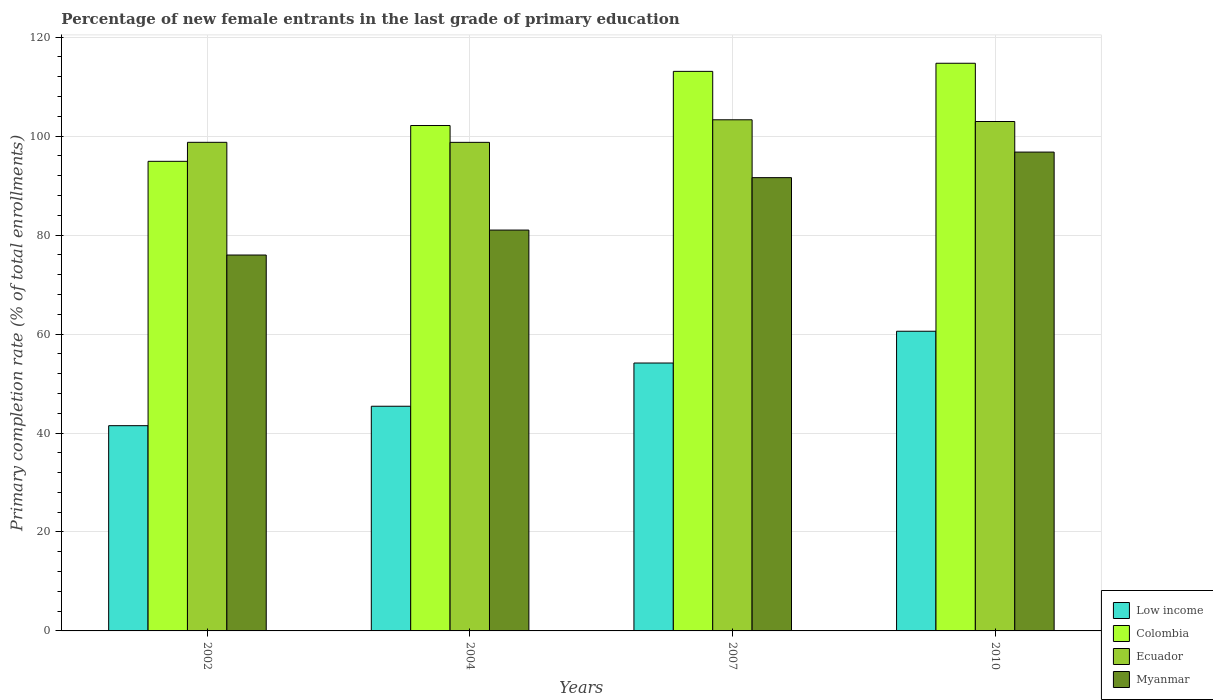How many different coloured bars are there?
Your response must be concise. 4. How many groups of bars are there?
Keep it short and to the point. 4. Are the number of bars on each tick of the X-axis equal?
Your answer should be compact. Yes. How many bars are there on the 4th tick from the left?
Provide a succinct answer. 4. In how many cases, is the number of bars for a given year not equal to the number of legend labels?
Ensure brevity in your answer.  0. What is the percentage of new female entrants in Ecuador in 2010?
Your answer should be very brief. 102.95. Across all years, what is the maximum percentage of new female entrants in Colombia?
Your response must be concise. 114.73. Across all years, what is the minimum percentage of new female entrants in Myanmar?
Give a very brief answer. 75.97. What is the total percentage of new female entrants in Colombia in the graph?
Your response must be concise. 424.87. What is the difference between the percentage of new female entrants in Myanmar in 2004 and that in 2007?
Make the answer very short. -10.6. What is the difference between the percentage of new female entrants in Colombia in 2007 and the percentage of new female entrants in Ecuador in 2004?
Offer a very short reply. 14.35. What is the average percentage of new female entrants in Colombia per year?
Provide a succinct answer. 106.22. In the year 2004, what is the difference between the percentage of new female entrants in Ecuador and percentage of new female entrants in Low income?
Your response must be concise. 53.34. In how many years, is the percentage of new female entrants in Colombia greater than 72 %?
Keep it short and to the point. 4. What is the ratio of the percentage of new female entrants in Myanmar in 2002 to that in 2010?
Give a very brief answer. 0.79. What is the difference between the highest and the second highest percentage of new female entrants in Low income?
Your response must be concise. 6.42. What is the difference between the highest and the lowest percentage of new female entrants in Low income?
Keep it short and to the point. 19.09. Is the sum of the percentage of new female entrants in Ecuador in 2007 and 2010 greater than the maximum percentage of new female entrants in Myanmar across all years?
Your answer should be very brief. Yes. What does the 4th bar from the left in 2002 represents?
Give a very brief answer. Myanmar. What does the 2nd bar from the right in 2007 represents?
Your answer should be compact. Ecuador. How many bars are there?
Make the answer very short. 16. Are all the bars in the graph horizontal?
Provide a short and direct response. No. What is the difference between two consecutive major ticks on the Y-axis?
Offer a terse response. 20. Are the values on the major ticks of Y-axis written in scientific E-notation?
Offer a very short reply. No. Does the graph contain grids?
Give a very brief answer. Yes. How are the legend labels stacked?
Your answer should be compact. Vertical. What is the title of the graph?
Give a very brief answer. Percentage of new female entrants in the last grade of primary education. What is the label or title of the X-axis?
Offer a terse response. Years. What is the label or title of the Y-axis?
Your answer should be very brief. Primary completion rate (% of total enrollments). What is the Primary completion rate (% of total enrollments) of Low income in 2002?
Provide a short and direct response. 41.48. What is the Primary completion rate (% of total enrollments) of Colombia in 2002?
Offer a terse response. 94.91. What is the Primary completion rate (% of total enrollments) of Ecuador in 2002?
Your response must be concise. 98.75. What is the Primary completion rate (% of total enrollments) of Myanmar in 2002?
Provide a short and direct response. 75.97. What is the Primary completion rate (% of total enrollments) of Low income in 2004?
Offer a terse response. 45.41. What is the Primary completion rate (% of total enrollments) in Colombia in 2004?
Give a very brief answer. 102.14. What is the Primary completion rate (% of total enrollments) in Ecuador in 2004?
Provide a short and direct response. 98.74. What is the Primary completion rate (% of total enrollments) in Myanmar in 2004?
Your answer should be very brief. 81.01. What is the Primary completion rate (% of total enrollments) in Low income in 2007?
Your answer should be compact. 54.14. What is the Primary completion rate (% of total enrollments) of Colombia in 2007?
Your response must be concise. 113.09. What is the Primary completion rate (% of total enrollments) of Ecuador in 2007?
Keep it short and to the point. 103.3. What is the Primary completion rate (% of total enrollments) in Myanmar in 2007?
Your answer should be compact. 91.61. What is the Primary completion rate (% of total enrollments) in Low income in 2010?
Offer a terse response. 60.57. What is the Primary completion rate (% of total enrollments) of Colombia in 2010?
Give a very brief answer. 114.73. What is the Primary completion rate (% of total enrollments) in Ecuador in 2010?
Keep it short and to the point. 102.95. What is the Primary completion rate (% of total enrollments) in Myanmar in 2010?
Your answer should be very brief. 96.77. Across all years, what is the maximum Primary completion rate (% of total enrollments) in Low income?
Keep it short and to the point. 60.57. Across all years, what is the maximum Primary completion rate (% of total enrollments) in Colombia?
Keep it short and to the point. 114.73. Across all years, what is the maximum Primary completion rate (% of total enrollments) of Ecuador?
Offer a terse response. 103.3. Across all years, what is the maximum Primary completion rate (% of total enrollments) in Myanmar?
Ensure brevity in your answer.  96.77. Across all years, what is the minimum Primary completion rate (% of total enrollments) of Low income?
Your response must be concise. 41.48. Across all years, what is the minimum Primary completion rate (% of total enrollments) in Colombia?
Offer a very short reply. 94.91. Across all years, what is the minimum Primary completion rate (% of total enrollments) in Ecuador?
Your answer should be very brief. 98.74. Across all years, what is the minimum Primary completion rate (% of total enrollments) of Myanmar?
Offer a very short reply. 75.97. What is the total Primary completion rate (% of total enrollments) in Low income in the graph?
Your response must be concise. 201.6. What is the total Primary completion rate (% of total enrollments) in Colombia in the graph?
Keep it short and to the point. 424.87. What is the total Primary completion rate (% of total enrollments) of Ecuador in the graph?
Provide a succinct answer. 403.75. What is the total Primary completion rate (% of total enrollments) of Myanmar in the graph?
Your answer should be very brief. 345.37. What is the difference between the Primary completion rate (% of total enrollments) of Low income in 2002 and that in 2004?
Your answer should be very brief. -3.93. What is the difference between the Primary completion rate (% of total enrollments) of Colombia in 2002 and that in 2004?
Your response must be concise. -7.24. What is the difference between the Primary completion rate (% of total enrollments) in Ecuador in 2002 and that in 2004?
Your answer should be compact. 0. What is the difference between the Primary completion rate (% of total enrollments) in Myanmar in 2002 and that in 2004?
Give a very brief answer. -5.04. What is the difference between the Primary completion rate (% of total enrollments) of Low income in 2002 and that in 2007?
Offer a very short reply. -12.66. What is the difference between the Primary completion rate (% of total enrollments) of Colombia in 2002 and that in 2007?
Provide a short and direct response. -18.18. What is the difference between the Primary completion rate (% of total enrollments) of Ecuador in 2002 and that in 2007?
Make the answer very short. -4.55. What is the difference between the Primary completion rate (% of total enrollments) in Myanmar in 2002 and that in 2007?
Ensure brevity in your answer.  -15.64. What is the difference between the Primary completion rate (% of total enrollments) in Low income in 2002 and that in 2010?
Provide a succinct answer. -19.09. What is the difference between the Primary completion rate (% of total enrollments) in Colombia in 2002 and that in 2010?
Offer a terse response. -19.82. What is the difference between the Primary completion rate (% of total enrollments) of Ecuador in 2002 and that in 2010?
Your answer should be compact. -4.21. What is the difference between the Primary completion rate (% of total enrollments) in Myanmar in 2002 and that in 2010?
Your response must be concise. -20.8. What is the difference between the Primary completion rate (% of total enrollments) in Low income in 2004 and that in 2007?
Offer a very short reply. -8.73. What is the difference between the Primary completion rate (% of total enrollments) in Colombia in 2004 and that in 2007?
Your answer should be very brief. -10.94. What is the difference between the Primary completion rate (% of total enrollments) in Ecuador in 2004 and that in 2007?
Give a very brief answer. -4.56. What is the difference between the Primary completion rate (% of total enrollments) in Myanmar in 2004 and that in 2007?
Keep it short and to the point. -10.6. What is the difference between the Primary completion rate (% of total enrollments) of Low income in 2004 and that in 2010?
Your answer should be compact. -15.16. What is the difference between the Primary completion rate (% of total enrollments) of Colombia in 2004 and that in 2010?
Give a very brief answer. -12.58. What is the difference between the Primary completion rate (% of total enrollments) in Ecuador in 2004 and that in 2010?
Offer a very short reply. -4.21. What is the difference between the Primary completion rate (% of total enrollments) in Myanmar in 2004 and that in 2010?
Keep it short and to the point. -15.76. What is the difference between the Primary completion rate (% of total enrollments) in Low income in 2007 and that in 2010?
Your response must be concise. -6.42. What is the difference between the Primary completion rate (% of total enrollments) of Colombia in 2007 and that in 2010?
Give a very brief answer. -1.64. What is the difference between the Primary completion rate (% of total enrollments) of Ecuador in 2007 and that in 2010?
Keep it short and to the point. 0.35. What is the difference between the Primary completion rate (% of total enrollments) in Myanmar in 2007 and that in 2010?
Make the answer very short. -5.17. What is the difference between the Primary completion rate (% of total enrollments) in Low income in 2002 and the Primary completion rate (% of total enrollments) in Colombia in 2004?
Make the answer very short. -60.66. What is the difference between the Primary completion rate (% of total enrollments) of Low income in 2002 and the Primary completion rate (% of total enrollments) of Ecuador in 2004?
Make the answer very short. -57.26. What is the difference between the Primary completion rate (% of total enrollments) of Low income in 2002 and the Primary completion rate (% of total enrollments) of Myanmar in 2004?
Your answer should be compact. -39.53. What is the difference between the Primary completion rate (% of total enrollments) in Colombia in 2002 and the Primary completion rate (% of total enrollments) in Ecuador in 2004?
Keep it short and to the point. -3.83. What is the difference between the Primary completion rate (% of total enrollments) in Colombia in 2002 and the Primary completion rate (% of total enrollments) in Myanmar in 2004?
Offer a terse response. 13.9. What is the difference between the Primary completion rate (% of total enrollments) of Ecuador in 2002 and the Primary completion rate (% of total enrollments) of Myanmar in 2004?
Provide a short and direct response. 17.74. What is the difference between the Primary completion rate (% of total enrollments) in Low income in 2002 and the Primary completion rate (% of total enrollments) in Colombia in 2007?
Offer a terse response. -71.61. What is the difference between the Primary completion rate (% of total enrollments) in Low income in 2002 and the Primary completion rate (% of total enrollments) in Ecuador in 2007?
Your answer should be compact. -61.82. What is the difference between the Primary completion rate (% of total enrollments) of Low income in 2002 and the Primary completion rate (% of total enrollments) of Myanmar in 2007?
Ensure brevity in your answer.  -50.13. What is the difference between the Primary completion rate (% of total enrollments) of Colombia in 2002 and the Primary completion rate (% of total enrollments) of Ecuador in 2007?
Provide a succinct answer. -8.39. What is the difference between the Primary completion rate (% of total enrollments) of Colombia in 2002 and the Primary completion rate (% of total enrollments) of Myanmar in 2007?
Offer a very short reply. 3.3. What is the difference between the Primary completion rate (% of total enrollments) in Ecuador in 2002 and the Primary completion rate (% of total enrollments) in Myanmar in 2007?
Your answer should be very brief. 7.14. What is the difference between the Primary completion rate (% of total enrollments) of Low income in 2002 and the Primary completion rate (% of total enrollments) of Colombia in 2010?
Give a very brief answer. -73.25. What is the difference between the Primary completion rate (% of total enrollments) in Low income in 2002 and the Primary completion rate (% of total enrollments) in Ecuador in 2010?
Keep it short and to the point. -61.47. What is the difference between the Primary completion rate (% of total enrollments) of Low income in 2002 and the Primary completion rate (% of total enrollments) of Myanmar in 2010?
Offer a very short reply. -55.29. What is the difference between the Primary completion rate (% of total enrollments) of Colombia in 2002 and the Primary completion rate (% of total enrollments) of Ecuador in 2010?
Offer a terse response. -8.05. What is the difference between the Primary completion rate (% of total enrollments) of Colombia in 2002 and the Primary completion rate (% of total enrollments) of Myanmar in 2010?
Ensure brevity in your answer.  -1.87. What is the difference between the Primary completion rate (% of total enrollments) of Ecuador in 2002 and the Primary completion rate (% of total enrollments) of Myanmar in 2010?
Offer a very short reply. 1.97. What is the difference between the Primary completion rate (% of total enrollments) in Low income in 2004 and the Primary completion rate (% of total enrollments) in Colombia in 2007?
Your answer should be compact. -67.68. What is the difference between the Primary completion rate (% of total enrollments) in Low income in 2004 and the Primary completion rate (% of total enrollments) in Ecuador in 2007?
Your answer should be very brief. -57.9. What is the difference between the Primary completion rate (% of total enrollments) in Low income in 2004 and the Primary completion rate (% of total enrollments) in Myanmar in 2007?
Offer a terse response. -46.2. What is the difference between the Primary completion rate (% of total enrollments) in Colombia in 2004 and the Primary completion rate (% of total enrollments) in Ecuador in 2007?
Ensure brevity in your answer.  -1.16. What is the difference between the Primary completion rate (% of total enrollments) in Colombia in 2004 and the Primary completion rate (% of total enrollments) in Myanmar in 2007?
Your answer should be compact. 10.54. What is the difference between the Primary completion rate (% of total enrollments) in Ecuador in 2004 and the Primary completion rate (% of total enrollments) in Myanmar in 2007?
Give a very brief answer. 7.13. What is the difference between the Primary completion rate (% of total enrollments) in Low income in 2004 and the Primary completion rate (% of total enrollments) in Colombia in 2010?
Your response must be concise. -69.32. What is the difference between the Primary completion rate (% of total enrollments) of Low income in 2004 and the Primary completion rate (% of total enrollments) of Ecuador in 2010?
Provide a succinct answer. -57.55. What is the difference between the Primary completion rate (% of total enrollments) of Low income in 2004 and the Primary completion rate (% of total enrollments) of Myanmar in 2010?
Offer a very short reply. -51.37. What is the difference between the Primary completion rate (% of total enrollments) of Colombia in 2004 and the Primary completion rate (% of total enrollments) of Ecuador in 2010?
Keep it short and to the point. -0.81. What is the difference between the Primary completion rate (% of total enrollments) in Colombia in 2004 and the Primary completion rate (% of total enrollments) in Myanmar in 2010?
Keep it short and to the point. 5.37. What is the difference between the Primary completion rate (% of total enrollments) of Ecuador in 2004 and the Primary completion rate (% of total enrollments) of Myanmar in 2010?
Your answer should be compact. 1.97. What is the difference between the Primary completion rate (% of total enrollments) of Low income in 2007 and the Primary completion rate (% of total enrollments) of Colombia in 2010?
Give a very brief answer. -60.58. What is the difference between the Primary completion rate (% of total enrollments) of Low income in 2007 and the Primary completion rate (% of total enrollments) of Ecuador in 2010?
Offer a terse response. -48.81. What is the difference between the Primary completion rate (% of total enrollments) in Low income in 2007 and the Primary completion rate (% of total enrollments) in Myanmar in 2010?
Make the answer very short. -42.63. What is the difference between the Primary completion rate (% of total enrollments) in Colombia in 2007 and the Primary completion rate (% of total enrollments) in Ecuador in 2010?
Provide a succinct answer. 10.13. What is the difference between the Primary completion rate (% of total enrollments) of Colombia in 2007 and the Primary completion rate (% of total enrollments) of Myanmar in 2010?
Offer a terse response. 16.32. What is the difference between the Primary completion rate (% of total enrollments) of Ecuador in 2007 and the Primary completion rate (% of total enrollments) of Myanmar in 2010?
Your response must be concise. 6.53. What is the average Primary completion rate (% of total enrollments) in Low income per year?
Offer a very short reply. 50.4. What is the average Primary completion rate (% of total enrollments) in Colombia per year?
Give a very brief answer. 106.22. What is the average Primary completion rate (% of total enrollments) of Ecuador per year?
Offer a terse response. 100.94. What is the average Primary completion rate (% of total enrollments) in Myanmar per year?
Your response must be concise. 86.34. In the year 2002, what is the difference between the Primary completion rate (% of total enrollments) in Low income and Primary completion rate (% of total enrollments) in Colombia?
Offer a very short reply. -53.43. In the year 2002, what is the difference between the Primary completion rate (% of total enrollments) in Low income and Primary completion rate (% of total enrollments) in Ecuador?
Offer a very short reply. -57.27. In the year 2002, what is the difference between the Primary completion rate (% of total enrollments) in Low income and Primary completion rate (% of total enrollments) in Myanmar?
Ensure brevity in your answer.  -34.49. In the year 2002, what is the difference between the Primary completion rate (% of total enrollments) of Colombia and Primary completion rate (% of total enrollments) of Ecuador?
Give a very brief answer. -3.84. In the year 2002, what is the difference between the Primary completion rate (% of total enrollments) of Colombia and Primary completion rate (% of total enrollments) of Myanmar?
Make the answer very short. 18.94. In the year 2002, what is the difference between the Primary completion rate (% of total enrollments) in Ecuador and Primary completion rate (% of total enrollments) in Myanmar?
Provide a succinct answer. 22.78. In the year 2004, what is the difference between the Primary completion rate (% of total enrollments) of Low income and Primary completion rate (% of total enrollments) of Colombia?
Make the answer very short. -56.74. In the year 2004, what is the difference between the Primary completion rate (% of total enrollments) in Low income and Primary completion rate (% of total enrollments) in Ecuador?
Make the answer very short. -53.34. In the year 2004, what is the difference between the Primary completion rate (% of total enrollments) of Low income and Primary completion rate (% of total enrollments) of Myanmar?
Provide a short and direct response. -35.6. In the year 2004, what is the difference between the Primary completion rate (% of total enrollments) of Colombia and Primary completion rate (% of total enrollments) of Ecuador?
Ensure brevity in your answer.  3.4. In the year 2004, what is the difference between the Primary completion rate (% of total enrollments) in Colombia and Primary completion rate (% of total enrollments) in Myanmar?
Your answer should be compact. 21.13. In the year 2004, what is the difference between the Primary completion rate (% of total enrollments) in Ecuador and Primary completion rate (% of total enrollments) in Myanmar?
Provide a short and direct response. 17.73. In the year 2007, what is the difference between the Primary completion rate (% of total enrollments) in Low income and Primary completion rate (% of total enrollments) in Colombia?
Your answer should be very brief. -58.95. In the year 2007, what is the difference between the Primary completion rate (% of total enrollments) of Low income and Primary completion rate (% of total enrollments) of Ecuador?
Your answer should be very brief. -49.16. In the year 2007, what is the difference between the Primary completion rate (% of total enrollments) in Low income and Primary completion rate (% of total enrollments) in Myanmar?
Keep it short and to the point. -37.47. In the year 2007, what is the difference between the Primary completion rate (% of total enrollments) in Colombia and Primary completion rate (% of total enrollments) in Ecuador?
Your answer should be compact. 9.79. In the year 2007, what is the difference between the Primary completion rate (% of total enrollments) of Colombia and Primary completion rate (% of total enrollments) of Myanmar?
Give a very brief answer. 21.48. In the year 2007, what is the difference between the Primary completion rate (% of total enrollments) in Ecuador and Primary completion rate (% of total enrollments) in Myanmar?
Offer a very short reply. 11.69. In the year 2010, what is the difference between the Primary completion rate (% of total enrollments) in Low income and Primary completion rate (% of total enrollments) in Colombia?
Ensure brevity in your answer.  -54.16. In the year 2010, what is the difference between the Primary completion rate (% of total enrollments) of Low income and Primary completion rate (% of total enrollments) of Ecuador?
Provide a short and direct response. -42.39. In the year 2010, what is the difference between the Primary completion rate (% of total enrollments) in Low income and Primary completion rate (% of total enrollments) in Myanmar?
Your answer should be very brief. -36.21. In the year 2010, what is the difference between the Primary completion rate (% of total enrollments) in Colombia and Primary completion rate (% of total enrollments) in Ecuador?
Your response must be concise. 11.77. In the year 2010, what is the difference between the Primary completion rate (% of total enrollments) of Colombia and Primary completion rate (% of total enrollments) of Myanmar?
Provide a short and direct response. 17.95. In the year 2010, what is the difference between the Primary completion rate (% of total enrollments) of Ecuador and Primary completion rate (% of total enrollments) of Myanmar?
Ensure brevity in your answer.  6.18. What is the ratio of the Primary completion rate (% of total enrollments) in Low income in 2002 to that in 2004?
Your answer should be very brief. 0.91. What is the ratio of the Primary completion rate (% of total enrollments) of Colombia in 2002 to that in 2004?
Ensure brevity in your answer.  0.93. What is the ratio of the Primary completion rate (% of total enrollments) in Myanmar in 2002 to that in 2004?
Your answer should be very brief. 0.94. What is the ratio of the Primary completion rate (% of total enrollments) of Low income in 2002 to that in 2007?
Your answer should be compact. 0.77. What is the ratio of the Primary completion rate (% of total enrollments) of Colombia in 2002 to that in 2007?
Your answer should be very brief. 0.84. What is the ratio of the Primary completion rate (% of total enrollments) in Ecuador in 2002 to that in 2007?
Ensure brevity in your answer.  0.96. What is the ratio of the Primary completion rate (% of total enrollments) of Myanmar in 2002 to that in 2007?
Your response must be concise. 0.83. What is the ratio of the Primary completion rate (% of total enrollments) in Low income in 2002 to that in 2010?
Keep it short and to the point. 0.68. What is the ratio of the Primary completion rate (% of total enrollments) of Colombia in 2002 to that in 2010?
Provide a short and direct response. 0.83. What is the ratio of the Primary completion rate (% of total enrollments) of Ecuador in 2002 to that in 2010?
Make the answer very short. 0.96. What is the ratio of the Primary completion rate (% of total enrollments) of Myanmar in 2002 to that in 2010?
Your answer should be very brief. 0.79. What is the ratio of the Primary completion rate (% of total enrollments) of Low income in 2004 to that in 2007?
Offer a terse response. 0.84. What is the ratio of the Primary completion rate (% of total enrollments) of Colombia in 2004 to that in 2007?
Ensure brevity in your answer.  0.9. What is the ratio of the Primary completion rate (% of total enrollments) of Ecuador in 2004 to that in 2007?
Make the answer very short. 0.96. What is the ratio of the Primary completion rate (% of total enrollments) of Myanmar in 2004 to that in 2007?
Provide a succinct answer. 0.88. What is the ratio of the Primary completion rate (% of total enrollments) of Low income in 2004 to that in 2010?
Keep it short and to the point. 0.75. What is the ratio of the Primary completion rate (% of total enrollments) in Colombia in 2004 to that in 2010?
Provide a short and direct response. 0.89. What is the ratio of the Primary completion rate (% of total enrollments) in Ecuador in 2004 to that in 2010?
Ensure brevity in your answer.  0.96. What is the ratio of the Primary completion rate (% of total enrollments) in Myanmar in 2004 to that in 2010?
Give a very brief answer. 0.84. What is the ratio of the Primary completion rate (% of total enrollments) of Low income in 2007 to that in 2010?
Keep it short and to the point. 0.89. What is the ratio of the Primary completion rate (% of total enrollments) of Colombia in 2007 to that in 2010?
Your response must be concise. 0.99. What is the ratio of the Primary completion rate (% of total enrollments) of Ecuador in 2007 to that in 2010?
Your response must be concise. 1. What is the ratio of the Primary completion rate (% of total enrollments) of Myanmar in 2007 to that in 2010?
Offer a very short reply. 0.95. What is the difference between the highest and the second highest Primary completion rate (% of total enrollments) of Low income?
Make the answer very short. 6.42. What is the difference between the highest and the second highest Primary completion rate (% of total enrollments) in Colombia?
Provide a short and direct response. 1.64. What is the difference between the highest and the second highest Primary completion rate (% of total enrollments) of Ecuador?
Give a very brief answer. 0.35. What is the difference between the highest and the second highest Primary completion rate (% of total enrollments) in Myanmar?
Keep it short and to the point. 5.17. What is the difference between the highest and the lowest Primary completion rate (% of total enrollments) in Low income?
Provide a succinct answer. 19.09. What is the difference between the highest and the lowest Primary completion rate (% of total enrollments) of Colombia?
Your answer should be compact. 19.82. What is the difference between the highest and the lowest Primary completion rate (% of total enrollments) in Ecuador?
Provide a succinct answer. 4.56. What is the difference between the highest and the lowest Primary completion rate (% of total enrollments) of Myanmar?
Provide a succinct answer. 20.8. 